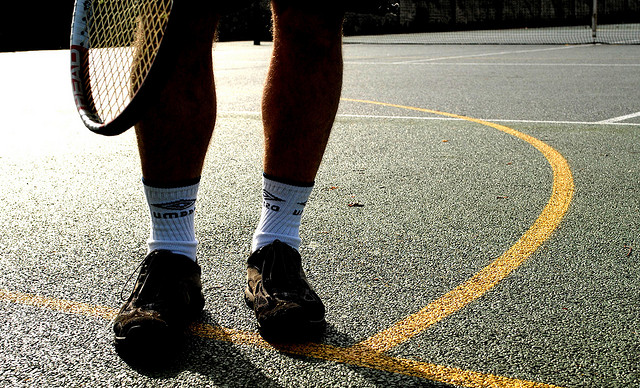Extract all visible text content from this image. umdd 20 